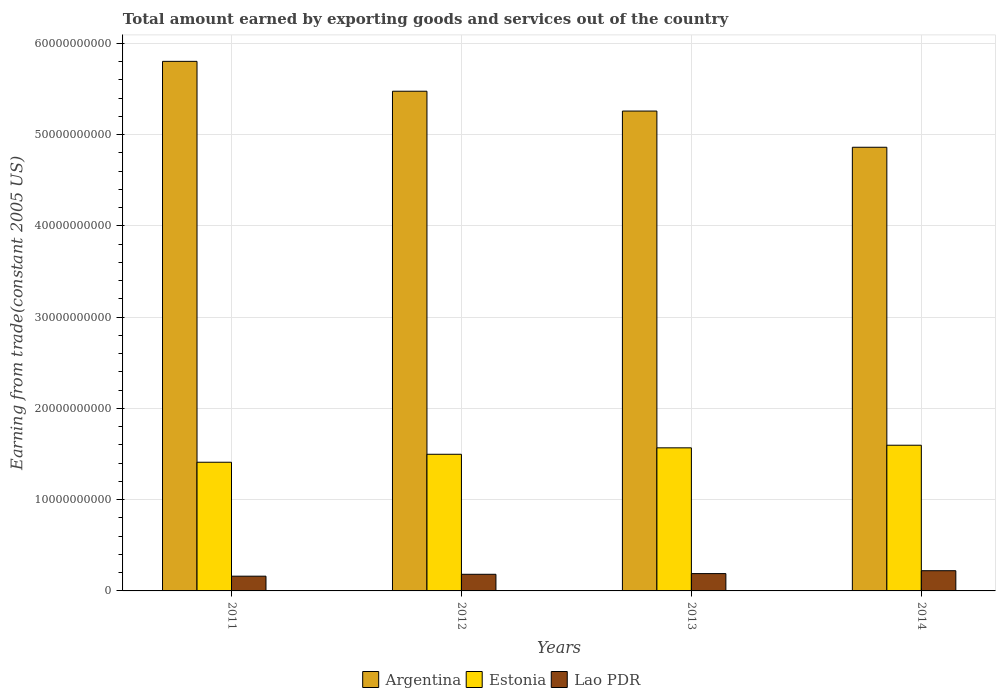How many different coloured bars are there?
Ensure brevity in your answer.  3. How many bars are there on the 2nd tick from the left?
Provide a succinct answer. 3. What is the total amount earned by exporting goods and services in Argentina in 2014?
Ensure brevity in your answer.  4.86e+1. Across all years, what is the maximum total amount earned by exporting goods and services in Estonia?
Ensure brevity in your answer.  1.60e+1. Across all years, what is the minimum total amount earned by exporting goods and services in Argentina?
Offer a very short reply. 4.86e+1. In which year was the total amount earned by exporting goods and services in Estonia maximum?
Your answer should be very brief. 2014. In which year was the total amount earned by exporting goods and services in Argentina minimum?
Provide a succinct answer. 2014. What is the total total amount earned by exporting goods and services in Argentina in the graph?
Make the answer very short. 2.14e+11. What is the difference between the total amount earned by exporting goods and services in Argentina in 2011 and that in 2014?
Keep it short and to the point. 9.41e+09. What is the difference between the total amount earned by exporting goods and services in Argentina in 2011 and the total amount earned by exporting goods and services in Estonia in 2012?
Provide a succinct answer. 4.31e+1. What is the average total amount earned by exporting goods and services in Lao PDR per year?
Your response must be concise. 1.89e+09. In the year 2013, what is the difference between the total amount earned by exporting goods and services in Argentina and total amount earned by exporting goods and services in Lao PDR?
Ensure brevity in your answer.  5.07e+1. In how many years, is the total amount earned by exporting goods and services in Lao PDR greater than 28000000000 US$?
Your answer should be very brief. 0. What is the ratio of the total amount earned by exporting goods and services in Lao PDR in 2012 to that in 2013?
Give a very brief answer. 0.96. Is the total amount earned by exporting goods and services in Argentina in 2012 less than that in 2013?
Ensure brevity in your answer.  No. Is the difference between the total amount earned by exporting goods and services in Argentina in 2011 and 2014 greater than the difference between the total amount earned by exporting goods and services in Lao PDR in 2011 and 2014?
Make the answer very short. Yes. What is the difference between the highest and the second highest total amount earned by exporting goods and services in Estonia?
Provide a succinct answer. 2.87e+08. What is the difference between the highest and the lowest total amount earned by exporting goods and services in Estonia?
Offer a terse response. 1.87e+09. What does the 3rd bar from the left in 2013 represents?
Keep it short and to the point. Lao PDR. What does the 3rd bar from the right in 2011 represents?
Provide a short and direct response. Argentina. Is it the case that in every year, the sum of the total amount earned by exporting goods and services in Argentina and total amount earned by exporting goods and services in Lao PDR is greater than the total amount earned by exporting goods and services in Estonia?
Your response must be concise. Yes. Are all the bars in the graph horizontal?
Ensure brevity in your answer.  No. What is the difference between two consecutive major ticks on the Y-axis?
Give a very brief answer. 1.00e+1. Are the values on the major ticks of Y-axis written in scientific E-notation?
Make the answer very short. No. Does the graph contain any zero values?
Give a very brief answer. No. Does the graph contain grids?
Your response must be concise. Yes. Where does the legend appear in the graph?
Give a very brief answer. Bottom center. How many legend labels are there?
Give a very brief answer. 3. What is the title of the graph?
Ensure brevity in your answer.  Total amount earned by exporting goods and services out of the country. Does "Bolivia" appear as one of the legend labels in the graph?
Offer a very short reply. No. What is the label or title of the X-axis?
Your response must be concise. Years. What is the label or title of the Y-axis?
Provide a short and direct response. Earning from trade(constant 2005 US). What is the Earning from trade(constant 2005 US) in Argentina in 2011?
Give a very brief answer. 5.80e+1. What is the Earning from trade(constant 2005 US) of Estonia in 2011?
Your answer should be compact. 1.41e+1. What is the Earning from trade(constant 2005 US) of Lao PDR in 2011?
Your answer should be compact. 1.62e+09. What is the Earning from trade(constant 2005 US) of Argentina in 2012?
Your response must be concise. 5.48e+1. What is the Earning from trade(constant 2005 US) of Estonia in 2012?
Offer a terse response. 1.50e+1. What is the Earning from trade(constant 2005 US) in Lao PDR in 2012?
Provide a short and direct response. 1.82e+09. What is the Earning from trade(constant 2005 US) of Argentina in 2013?
Keep it short and to the point. 5.26e+1. What is the Earning from trade(constant 2005 US) of Estonia in 2013?
Your answer should be very brief. 1.57e+1. What is the Earning from trade(constant 2005 US) of Lao PDR in 2013?
Give a very brief answer. 1.90e+09. What is the Earning from trade(constant 2005 US) in Argentina in 2014?
Offer a very short reply. 4.86e+1. What is the Earning from trade(constant 2005 US) of Estonia in 2014?
Make the answer very short. 1.60e+1. What is the Earning from trade(constant 2005 US) of Lao PDR in 2014?
Offer a terse response. 2.21e+09. Across all years, what is the maximum Earning from trade(constant 2005 US) of Argentina?
Your answer should be compact. 5.80e+1. Across all years, what is the maximum Earning from trade(constant 2005 US) in Estonia?
Keep it short and to the point. 1.60e+1. Across all years, what is the maximum Earning from trade(constant 2005 US) of Lao PDR?
Your response must be concise. 2.21e+09. Across all years, what is the minimum Earning from trade(constant 2005 US) in Argentina?
Your answer should be compact. 4.86e+1. Across all years, what is the minimum Earning from trade(constant 2005 US) of Estonia?
Provide a succinct answer. 1.41e+1. Across all years, what is the minimum Earning from trade(constant 2005 US) of Lao PDR?
Your answer should be very brief. 1.62e+09. What is the total Earning from trade(constant 2005 US) of Argentina in the graph?
Ensure brevity in your answer.  2.14e+11. What is the total Earning from trade(constant 2005 US) in Estonia in the graph?
Ensure brevity in your answer.  6.07e+1. What is the total Earning from trade(constant 2005 US) in Lao PDR in the graph?
Provide a short and direct response. 7.55e+09. What is the difference between the Earning from trade(constant 2005 US) in Argentina in 2011 and that in 2012?
Your answer should be very brief. 3.27e+09. What is the difference between the Earning from trade(constant 2005 US) of Estonia in 2011 and that in 2012?
Give a very brief answer. -8.74e+08. What is the difference between the Earning from trade(constant 2005 US) in Lao PDR in 2011 and that in 2012?
Offer a very short reply. -2.08e+08. What is the difference between the Earning from trade(constant 2005 US) in Argentina in 2011 and that in 2013?
Give a very brief answer. 5.45e+09. What is the difference between the Earning from trade(constant 2005 US) of Estonia in 2011 and that in 2013?
Provide a short and direct response. -1.58e+09. What is the difference between the Earning from trade(constant 2005 US) in Lao PDR in 2011 and that in 2013?
Keep it short and to the point. -2.83e+08. What is the difference between the Earning from trade(constant 2005 US) of Argentina in 2011 and that in 2014?
Your response must be concise. 9.41e+09. What is the difference between the Earning from trade(constant 2005 US) of Estonia in 2011 and that in 2014?
Provide a succinct answer. -1.87e+09. What is the difference between the Earning from trade(constant 2005 US) of Lao PDR in 2011 and that in 2014?
Your answer should be compact. -5.99e+08. What is the difference between the Earning from trade(constant 2005 US) of Argentina in 2012 and that in 2013?
Your response must be concise. 2.17e+09. What is the difference between the Earning from trade(constant 2005 US) of Estonia in 2012 and that in 2013?
Ensure brevity in your answer.  -7.05e+08. What is the difference between the Earning from trade(constant 2005 US) in Lao PDR in 2012 and that in 2013?
Give a very brief answer. -7.53e+07. What is the difference between the Earning from trade(constant 2005 US) of Argentina in 2012 and that in 2014?
Offer a very short reply. 6.14e+09. What is the difference between the Earning from trade(constant 2005 US) in Estonia in 2012 and that in 2014?
Your response must be concise. -9.92e+08. What is the difference between the Earning from trade(constant 2005 US) in Lao PDR in 2012 and that in 2014?
Make the answer very short. -3.91e+08. What is the difference between the Earning from trade(constant 2005 US) in Argentina in 2013 and that in 2014?
Your response must be concise. 3.97e+09. What is the difference between the Earning from trade(constant 2005 US) in Estonia in 2013 and that in 2014?
Provide a succinct answer. -2.87e+08. What is the difference between the Earning from trade(constant 2005 US) in Lao PDR in 2013 and that in 2014?
Offer a terse response. -3.16e+08. What is the difference between the Earning from trade(constant 2005 US) of Argentina in 2011 and the Earning from trade(constant 2005 US) of Estonia in 2012?
Your answer should be very brief. 4.31e+1. What is the difference between the Earning from trade(constant 2005 US) of Argentina in 2011 and the Earning from trade(constant 2005 US) of Lao PDR in 2012?
Make the answer very short. 5.62e+1. What is the difference between the Earning from trade(constant 2005 US) in Estonia in 2011 and the Earning from trade(constant 2005 US) in Lao PDR in 2012?
Your response must be concise. 1.23e+1. What is the difference between the Earning from trade(constant 2005 US) of Argentina in 2011 and the Earning from trade(constant 2005 US) of Estonia in 2013?
Keep it short and to the point. 4.24e+1. What is the difference between the Earning from trade(constant 2005 US) of Argentina in 2011 and the Earning from trade(constant 2005 US) of Lao PDR in 2013?
Provide a succinct answer. 5.61e+1. What is the difference between the Earning from trade(constant 2005 US) of Estonia in 2011 and the Earning from trade(constant 2005 US) of Lao PDR in 2013?
Provide a succinct answer. 1.22e+1. What is the difference between the Earning from trade(constant 2005 US) in Argentina in 2011 and the Earning from trade(constant 2005 US) in Estonia in 2014?
Your answer should be very brief. 4.21e+1. What is the difference between the Earning from trade(constant 2005 US) in Argentina in 2011 and the Earning from trade(constant 2005 US) in Lao PDR in 2014?
Ensure brevity in your answer.  5.58e+1. What is the difference between the Earning from trade(constant 2005 US) of Estonia in 2011 and the Earning from trade(constant 2005 US) of Lao PDR in 2014?
Make the answer very short. 1.19e+1. What is the difference between the Earning from trade(constant 2005 US) of Argentina in 2012 and the Earning from trade(constant 2005 US) of Estonia in 2013?
Keep it short and to the point. 3.91e+1. What is the difference between the Earning from trade(constant 2005 US) of Argentina in 2012 and the Earning from trade(constant 2005 US) of Lao PDR in 2013?
Keep it short and to the point. 5.29e+1. What is the difference between the Earning from trade(constant 2005 US) of Estonia in 2012 and the Earning from trade(constant 2005 US) of Lao PDR in 2013?
Provide a short and direct response. 1.31e+1. What is the difference between the Earning from trade(constant 2005 US) in Argentina in 2012 and the Earning from trade(constant 2005 US) in Estonia in 2014?
Your answer should be very brief. 3.88e+1. What is the difference between the Earning from trade(constant 2005 US) in Argentina in 2012 and the Earning from trade(constant 2005 US) in Lao PDR in 2014?
Keep it short and to the point. 5.25e+1. What is the difference between the Earning from trade(constant 2005 US) in Estonia in 2012 and the Earning from trade(constant 2005 US) in Lao PDR in 2014?
Offer a very short reply. 1.28e+1. What is the difference between the Earning from trade(constant 2005 US) of Argentina in 2013 and the Earning from trade(constant 2005 US) of Estonia in 2014?
Give a very brief answer. 3.66e+1. What is the difference between the Earning from trade(constant 2005 US) in Argentina in 2013 and the Earning from trade(constant 2005 US) in Lao PDR in 2014?
Ensure brevity in your answer.  5.04e+1. What is the difference between the Earning from trade(constant 2005 US) in Estonia in 2013 and the Earning from trade(constant 2005 US) in Lao PDR in 2014?
Provide a succinct answer. 1.35e+1. What is the average Earning from trade(constant 2005 US) of Argentina per year?
Your answer should be compact. 5.35e+1. What is the average Earning from trade(constant 2005 US) in Estonia per year?
Ensure brevity in your answer.  1.52e+1. What is the average Earning from trade(constant 2005 US) in Lao PDR per year?
Offer a very short reply. 1.89e+09. In the year 2011, what is the difference between the Earning from trade(constant 2005 US) of Argentina and Earning from trade(constant 2005 US) of Estonia?
Your answer should be very brief. 4.39e+1. In the year 2011, what is the difference between the Earning from trade(constant 2005 US) of Argentina and Earning from trade(constant 2005 US) of Lao PDR?
Ensure brevity in your answer.  5.64e+1. In the year 2011, what is the difference between the Earning from trade(constant 2005 US) of Estonia and Earning from trade(constant 2005 US) of Lao PDR?
Provide a succinct answer. 1.25e+1. In the year 2012, what is the difference between the Earning from trade(constant 2005 US) in Argentina and Earning from trade(constant 2005 US) in Estonia?
Your answer should be compact. 3.98e+1. In the year 2012, what is the difference between the Earning from trade(constant 2005 US) of Argentina and Earning from trade(constant 2005 US) of Lao PDR?
Keep it short and to the point. 5.29e+1. In the year 2012, what is the difference between the Earning from trade(constant 2005 US) in Estonia and Earning from trade(constant 2005 US) in Lao PDR?
Your answer should be very brief. 1.32e+1. In the year 2013, what is the difference between the Earning from trade(constant 2005 US) of Argentina and Earning from trade(constant 2005 US) of Estonia?
Provide a short and direct response. 3.69e+1. In the year 2013, what is the difference between the Earning from trade(constant 2005 US) of Argentina and Earning from trade(constant 2005 US) of Lao PDR?
Offer a very short reply. 5.07e+1. In the year 2013, what is the difference between the Earning from trade(constant 2005 US) in Estonia and Earning from trade(constant 2005 US) in Lao PDR?
Your response must be concise. 1.38e+1. In the year 2014, what is the difference between the Earning from trade(constant 2005 US) of Argentina and Earning from trade(constant 2005 US) of Estonia?
Provide a succinct answer. 3.27e+1. In the year 2014, what is the difference between the Earning from trade(constant 2005 US) in Argentina and Earning from trade(constant 2005 US) in Lao PDR?
Provide a succinct answer. 4.64e+1. In the year 2014, what is the difference between the Earning from trade(constant 2005 US) of Estonia and Earning from trade(constant 2005 US) of Lao PDR?
Provide a short and direct response. 1.38e+1. What is the ratio of the Earning from trade(constant 2005 US) in Argentina in 2011 to that in 2012?
Your response must be concise. 1.06. What is the ratio of the Earning from trade(constant 2005 US) of Estonia in 2011 to that in 2012?
Your answer should be very brief. 0.94. What is the ratio of the Earning from trade(constant 2005 US) of Lao PDR in 2011 to that in 2012?
Give a very brief answer. 0.89. What is the ratio of the Earning from trade(constant 2005 US) of Argentina in 2011 to that in 2013?
Give a very brief answer. 1.1. What is the ratio of the Earning from trade(constant 2005 US) in Estonia in 2011 to that in 2013?
Give a very brief answer. 0.9. What is the ratio of the Earning from trade(constant 2005 US) of Lao PDR in 2011 to that in 2013?
Ensure brevity in your answer.  0.85. What is the ratio of the Earning from trade(constant 2005 US) of Argentina in 2011 to that in 2014?
Make the answer very short. 1.19. What is the ratio of the Earning from trade(constant 2005 US) of Estonia in 2011 to that in 2014?
Give a very brief answer. 0.88. What is the ratio of the Earning from trade(constant 2005 US) of Lao PDR in 2011 to that in 2014?
Give a very brief answer. 0.73. What is the ratio of the Earning from trade(constant 2005 US) of Argentina in 2012 to that in 2013?
Ensure brevity in your answer.  1.04. What is the ratio of the Earning from trade(constant 2005 US) of Estonia in 2012 to that in 2013?
Provide a short and direct response. 0.95. What is the ratio of the Earning from trade(constant 2005 US) of Lao PDR in 2012 to that in 2013?
Keep it short and to the point. 0.96. What is the ratio of the Earning from trade(constant 2005 US) in Argentina in 2012 to that in 2014?
Provide a short and direct response. 1.13. What is the ratio of the Earning from trade(constant 2005 US) in Estonia in 2012 to that in 2014?
Provide a succinct answer. 0.94. What is the ratio of the Earning from trade(constant 2005 US) in Lao PDR in 2012 to that in 2014?
Offer a terse response. 0.82. What is the ratio of the Earning from trade(constant 2005 US) of Argentina in 2013 to that in 2014?
Your answer should be compact. 1.08. What is the ratio of the Earning from trade(constant 2005 US) of Lao PDR in 2013 to that in 2014?
Provide a succinct answer. 0.86. What is the difference between the highest and the second highest Earning from trade(constant 2005 US) of Argentina?
Keep it short and to the point. 3.27e+09. What is the difference between the highest and the second highest Earning from trade(constant 2005 US) of Estonia?
Give a very brief answer. 2.87e+08. What is the difference between the highest and the second highest Earning from trade(constant 2005 US) of Lao PDR?
Ensure brevity in your answer.  3.16e+08. What is the difference between the highest and the lowest Earning from trade(constant 2005 US) in Argentina?
Your answer should be very brief. 9.41e+09. What is the difference between the highest and the lowest Earning from trade(constant 2005 US) of Estonia?
Your response must be concise. 1.87e+09. What is the difference between the highest and the lowest Earning from trade(constant 2005 US) of Lao PDR?
Give a very brief answer. 5.99e+08. 